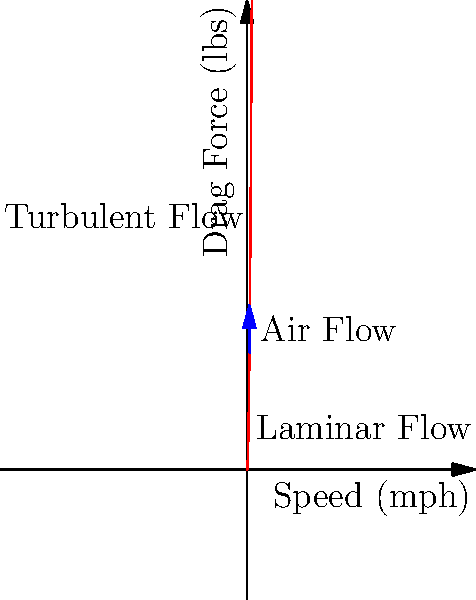A professional drag racer is analyzing the aerodynamic forces on their vehicle at different speeds. The graph shows the relationship between speed and drag force, with vector arrows indicating air flow. At what approximate speed (in mph) does the flow transition from laminar to turbulent, and how does this affect the drag force? Explain the implications for drag racing performance and strategy. To answer this question, we need to analyze the graph and understand the concepts of laminar and turbulent flow in relation to drag racing:

1. Observe the curve: The graph shows an exponential increase in drag force as speed increases.

2. Identify the transition point: The labels indicate that the flow transitions from laminar to turbulent at approximately 100-120 mph.

3. Understand laminar vs. turbulent flow:
   - Laminar flow: Smooth, predictable air movement around the vehicle.
   - Turbulent flow: Chaotic, unpredictable air movement with more mixing.

4. Analyze the effect on drag force:
   - In the laminar region, drag force increases gradually with speed.
   - At the transition point, there's a steeper increase in drag force.
   - In the turbulent region, drag force increases more rapidly with speed.

5. Calculate the drag force equation:
   The drag force (F) is proportional to the square of velocity (v):
   $$F = \frac{1}{2} \rho C_d A v^2$$
   Where ρ is air density, C_d is the drag coefficient, and A is the frontal area.

6. Implications for drag racing performance and strategy:
   a) Acceleration: Easier in the laminar region due to lower drag.
   b) Top speed: Limited by the rapid increase in drag force in the turbulent region.
   c) Vehicle design: Optimize aerodynamics to delay the transition to turbulent flow.
   d) Race strategy: Maximize acceleration in the laminar region, then manage power and aerodynamics in the turbulent region.
Answer: Transition at ~110 mph; drag force increases more rapidly in turbulent flow, affecting acceleration and top speed. 